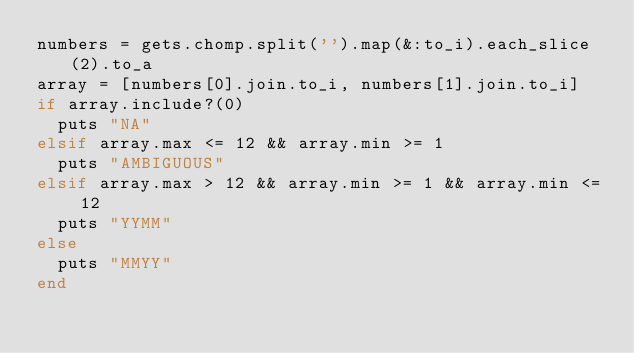<code> <loc_0><loc_0><loc_500><loc_500><_Ruby_>numbers = gets.chomp.split('').map(&:to_i).each_slice(2).to_a
array = [numbers[0].join.to_i, numbers[1].join.to_i]
if array.include?(0)
  puts "NA"
elsif array.max <= 12 && array.min >= 1
  puts "AMBIGUOUS"
elsif array.max > 12 && array.min >= 1 && array.min <= 12
  puts "YYMM"
else
  puts "MMYY"
end</code> 